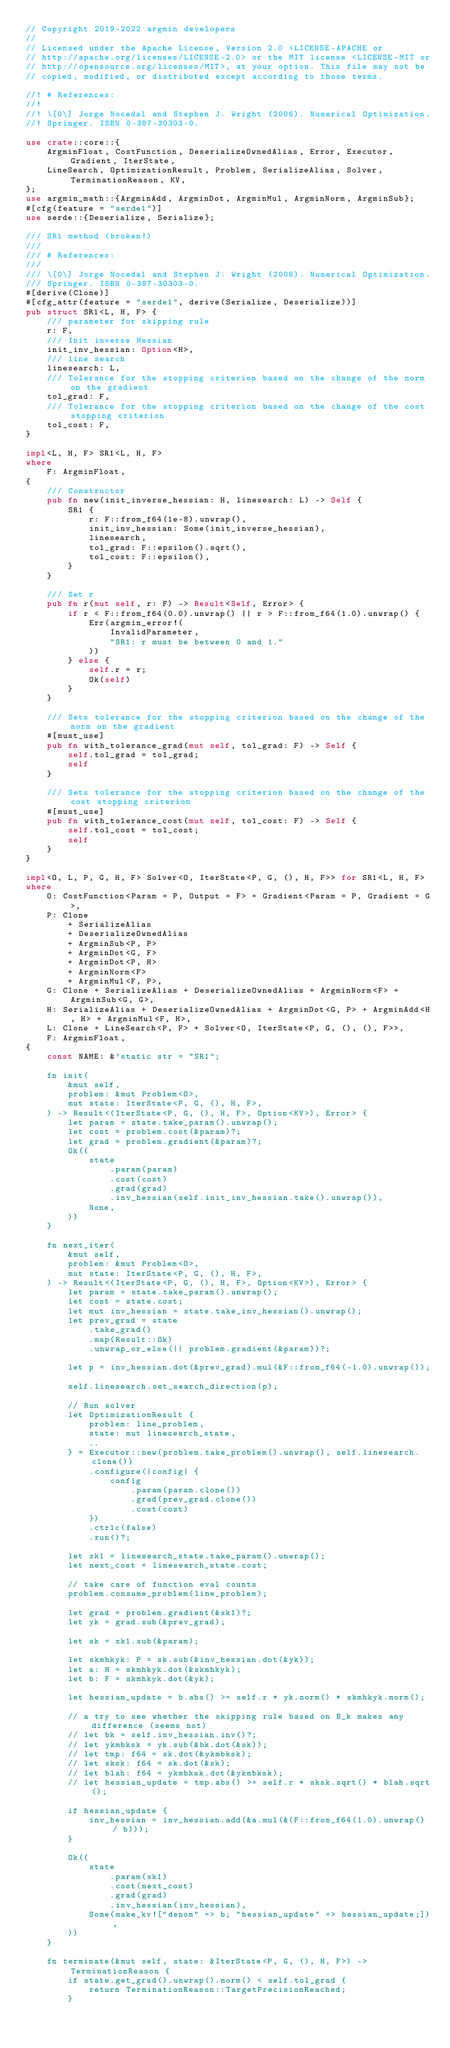<code> <loc_0><loc_0><loc_500><loc_500><_Rust_>// Copyright 2019-2022 argmin developers
//
// Licensed under the Apache License, Version 2.0 <LICENSE-APACHE or
// http://apache.org/licenses/LICENSE-2.0> or the MIT license <LICENSE-MIT or
// http://opensource.org/licenses/MIT>, at your option. This file may not be
// copied, modified, or distributed except according to those terms.

//! # References:
//!
//! \[0\] Jorge Nocedal and Stephen J. Wright (2006). Numerical Optimization.
//! Springer. ISBN 0-387-30303-0.

use crate::core::{
    ArgminFloat, CostFunction, DeserializeOwnedAlias, Error, Executor, Gradient, IterState,
    LineSearch, OptimizationResult, Problem, SerializeAlias, Solver, TerminationReason, KV,
};
use argmin_math::{ArgminAdd, ArgminDot, ArgminMul, ArgminNorm, ArgminSub};
#[cfg(feature = "serde1")]
use serde::{Deserialize, Serialize};

/// SR1 method (broken!)
///
/// # References:
///
/// \[0\] Jorge Nocedal and Stephen J. Wright (2006). Numerical Optimization.
/// Springer. ISBN 0-387-30303-0.
#[derive(Clone)]
#[cfg_attr(feature = "serde1", derive(Serialize, Deserialize))]
pub struct SR1<L, H, F> {
    /// parameter for skipping rule
    r: F,
    /// Init inverse Hessian
    init_inv_hessian: Option<H>,
    /// line search
    linesearch: L,
    /// Tolerance for the stopping criterion based on the change of the norm on the gradient
    tol_grad: F,
    /// Tolerance for the stopping criterion based on the change of the cost stopping criterion
    tol_cost: F,
}

impl<L, H, F> SR1<L, H, F>
where
    F: ArgminFloat,
{
    /// Constructor
    pub fn new(init_inverse_hessian: H, linesearch: L) -> Self {
        SR1 {
            r: F::from_f64(1e-8).unwrap(),
            init_inv_hessian: Some(init_inverse_hessian),
            linesearch,
            tol_grad: F::epsilon().sqrt(),
            tol_cost: F::epsilon(),
        }
    }

    /// Set r
    pub fn r(mut self, r: F) -> Result<Self, Error> {
        if r < F::from_f64(0.0).unwrap() || r > F::from_f64(1.0).unwrap() {
            Err(argmin_error!(
                InvalidParameter,
                "SR1: r must be between 0 and 1."
            ))
        } else {
            self.r = r;
            Ok(self)
        }
    }

    /// Sets tolerance for the stopping criterion based on the change of the norm on the gradient
    #[must_use]
    pub fn with_tolerance_grad(mut self, tol_grad: F) -> Self {
        self.tol_grad = tol_grad;
        self
    }

    /// Sets tolerance for the stopping criterion based on the change of the cost stopping criterion
    #[must_use]
    pub fn with_tolerance_cost(mut self, tol_cost: F) -> Self {
        self.tol_cost = tol_cost;
        self
    }
}

impl<O, L, P, G, H, F> Solver<O, IterState<P, G, (), H, F>> for SR1<L, H, F>
where
    O: CostFunction<Param = P, Output = F> + Gradient<Param = P, Gradient = G>,
    P: Clone
        + SerializeAlias
        + DeserializeOwnedAlias
        + ArgminSub<P, P>
        + ArgminDot<G, F>
        + ArgminDot<P, H>
        + ArgminNorm<F>
        + ArgminMul<F, P>,
    G: Clone + SerializeAlias + DeserializeOwnedAlias + ArgminNorm<F> + ArgminSub<G, G>,
    H: SerializeAlias + DeserializeOwnedAlias + ArgminDot<G, P> + ArgminAdd<H, H> + ArgminMul<F, H>,
    L: Clone + LineSearch<P, F> + Solver<O, IterState<P, G, (), (), F>>,
    F: ArgminFloat,
{
    const NAME: &'static str = "SR1";

    fn init(
        &mut self,
        problem: &mut Problem<O>,
        mut state: IterState<P, G, (), H, F>,
    ) -> Result<(IterState<P, G, (), H, F>, Option<KV>), Error> {
        let param = state.take_param().unwrap();
        let cost = problem.cost(&param)?;
        let grad = problem.gradient(&param)?;
        Ok((
            state
                .param(param)
                .cost(cost)
                .grad(grad)
                .inv_hessian(self.init_inv_hessian.take().unwrap()),
            None,
        ))
    }

    fn next_iter(
        &mut self,
        problem: &mut Problem<O>,
        mut state: IterState<P, G, (), H, F>,
    ) -> Result<(IterState<P, G, (), H, F>, Option<KV>), Error> {
        let param = state.take_param().unwrap();
        let cost = state.cost;
        let mut inv_hessian = state.take_inv_hessian().unwrap();
        let prev_grad = state
            .take_grad()
            .map(Result::Ok)
            .unwrap_or_else(|| problem.gradient(&param))?;

        let p = inv_hessian.dot(&prev_grad).mul(&F::from_f64(-1.0).unwrap());

        self.linesearch.set_search_direction(p);

        // Run solver
        let OptimizationResult {
            problem: line_problem,
            state: mut linesearch_state,
            ..
        } = Executor::new(problem.take_problem().unwrap(), self.linesearch.clone())
            .configure(|config| {
                config
                    .param(param.clone())
                    .grad(prev_grad.clone())
                    .cost(cost)
            })
            .ctrlc(false)
            .run()?;

        let xk1 = linesearch_state.take_param().unwrap();
        let next_cost = linesearch_state.cost;

        // take care of function eval counts
        problem.consume_problem(line_problem);

        let grad = problem.gradient(&xk1)?;
        let yk = grad.sub(&prev_grad);

        let sk = xk1.sub(&param);

        let skmhkyk: P = sk.sub(&inv_hessian.dot(&yk));
        let a: H = skmhkyk.dot(&skmhkyk);
        let b: F = skmhkyk.dot(&yk);

        let hessian_update = b.abs() >= self.r * yk.norm() * skmhkyk.norm();

        // a try to see whether the skipping rule based on B_k makes any difference (seems not)
        // let bk = self.inv_hessian.inv()?;
        // let ykmbksk = yk.sub(&bk.dot(&sk));
        // let tmp: f64 = sk.dot(&ykmbksk);
        // let sksk: f64 = sk.dot(&sk);
        // let blah: f64 = ykmbksk.dot(&ykmbksk);
        // let hessian_update = tmp.abs() >= self.r * sksk.sqrt() * blah.sqrt();

        if hessian_update {
            inv_hessian = inv_hessian.add(&a.mul(&(F::from_f64(1.0).unwrap() / b)));
        }

        Ok((
            state
                .param(xk1)
                .cost(next_cost)
                .grad(grad)
                .inv_hessian(inv_hessian),
            Some(make_kv!["denom" => b; "hessian_update" => hessian_update;]),
        ))
    }

    fn terminate(&mut self, state: &IterState<P, G, (), H, F>) -> TerminationReason {
        if state.get_grad().unwrap().norm() < self.tol_grad {
            return TerminationReason::TargetPrecisionReached;
        }</code> 